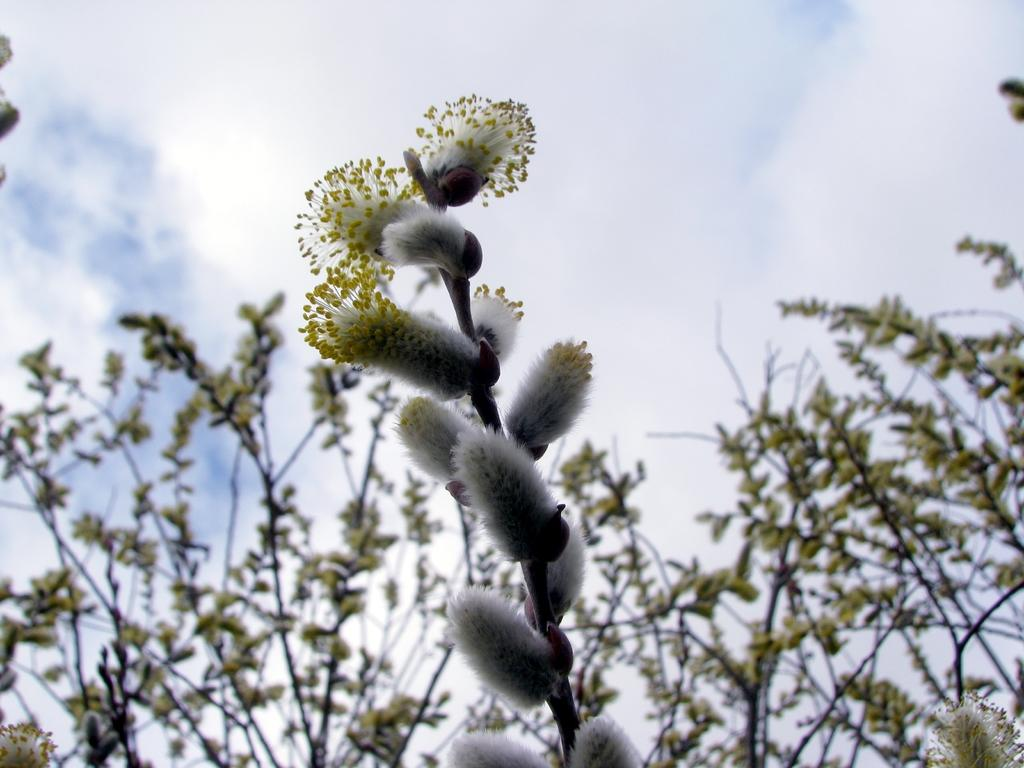What type of plants can be seen in the image? There are flowers in the image. What color are the flowers? The flowers are white. What else can be seen in the image besides the flowers? There are trees visible in the image. What is visible at the top of the image? The sky is visible at the top of the image. Where might this image have been taken? The image might have been taken in a garden. What type of trucks can be seen smashing the flowers in the image? There are no trucks or smashing of flowers present in the image. 